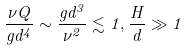Convert formula to latex. <formula><loc_0><loc_0><loc_500><loc_500>\frac { \nu Q } { g d ^ { 4 } } \sim \frac { g d ^ { 3 } } { \nu ^ { 2 } } \lesssim 1 , \frac { H } { d } \gg 1</formula> 